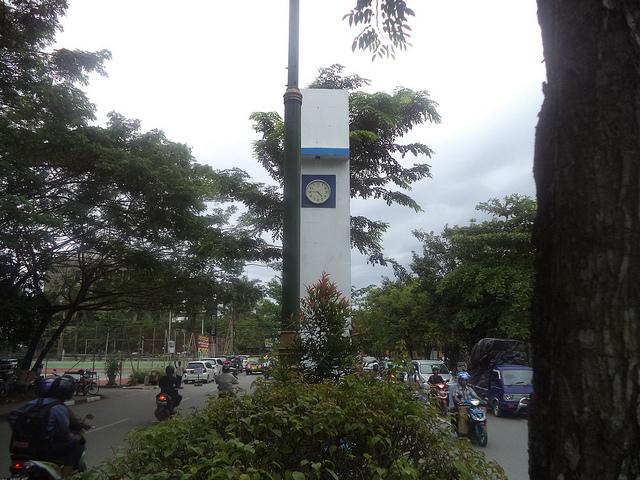Is the street busy?
Be succinct. Yes. What is the clock attached to?
Keep it brief. Post. Could it be 4:47 pm?
Concise answer only. Yes. 